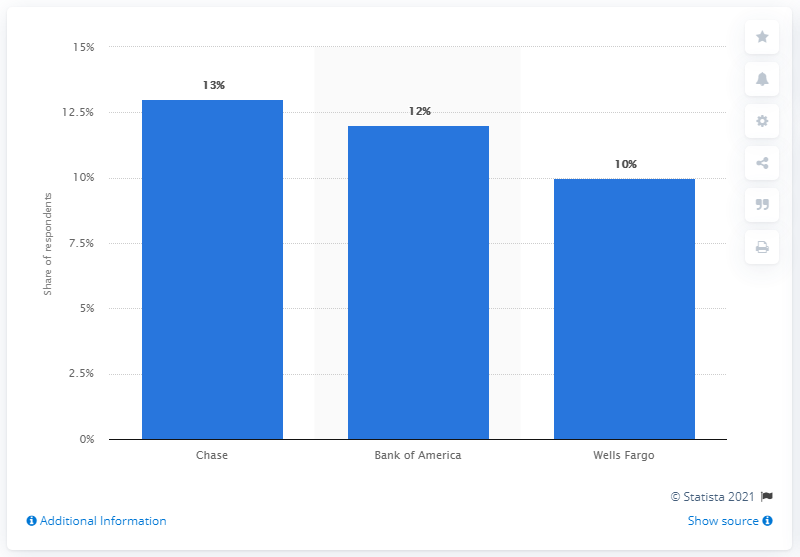Highlight a few significant elements in this photo. As of February 2015, Chase was the most trusted financial brand in the United States. 